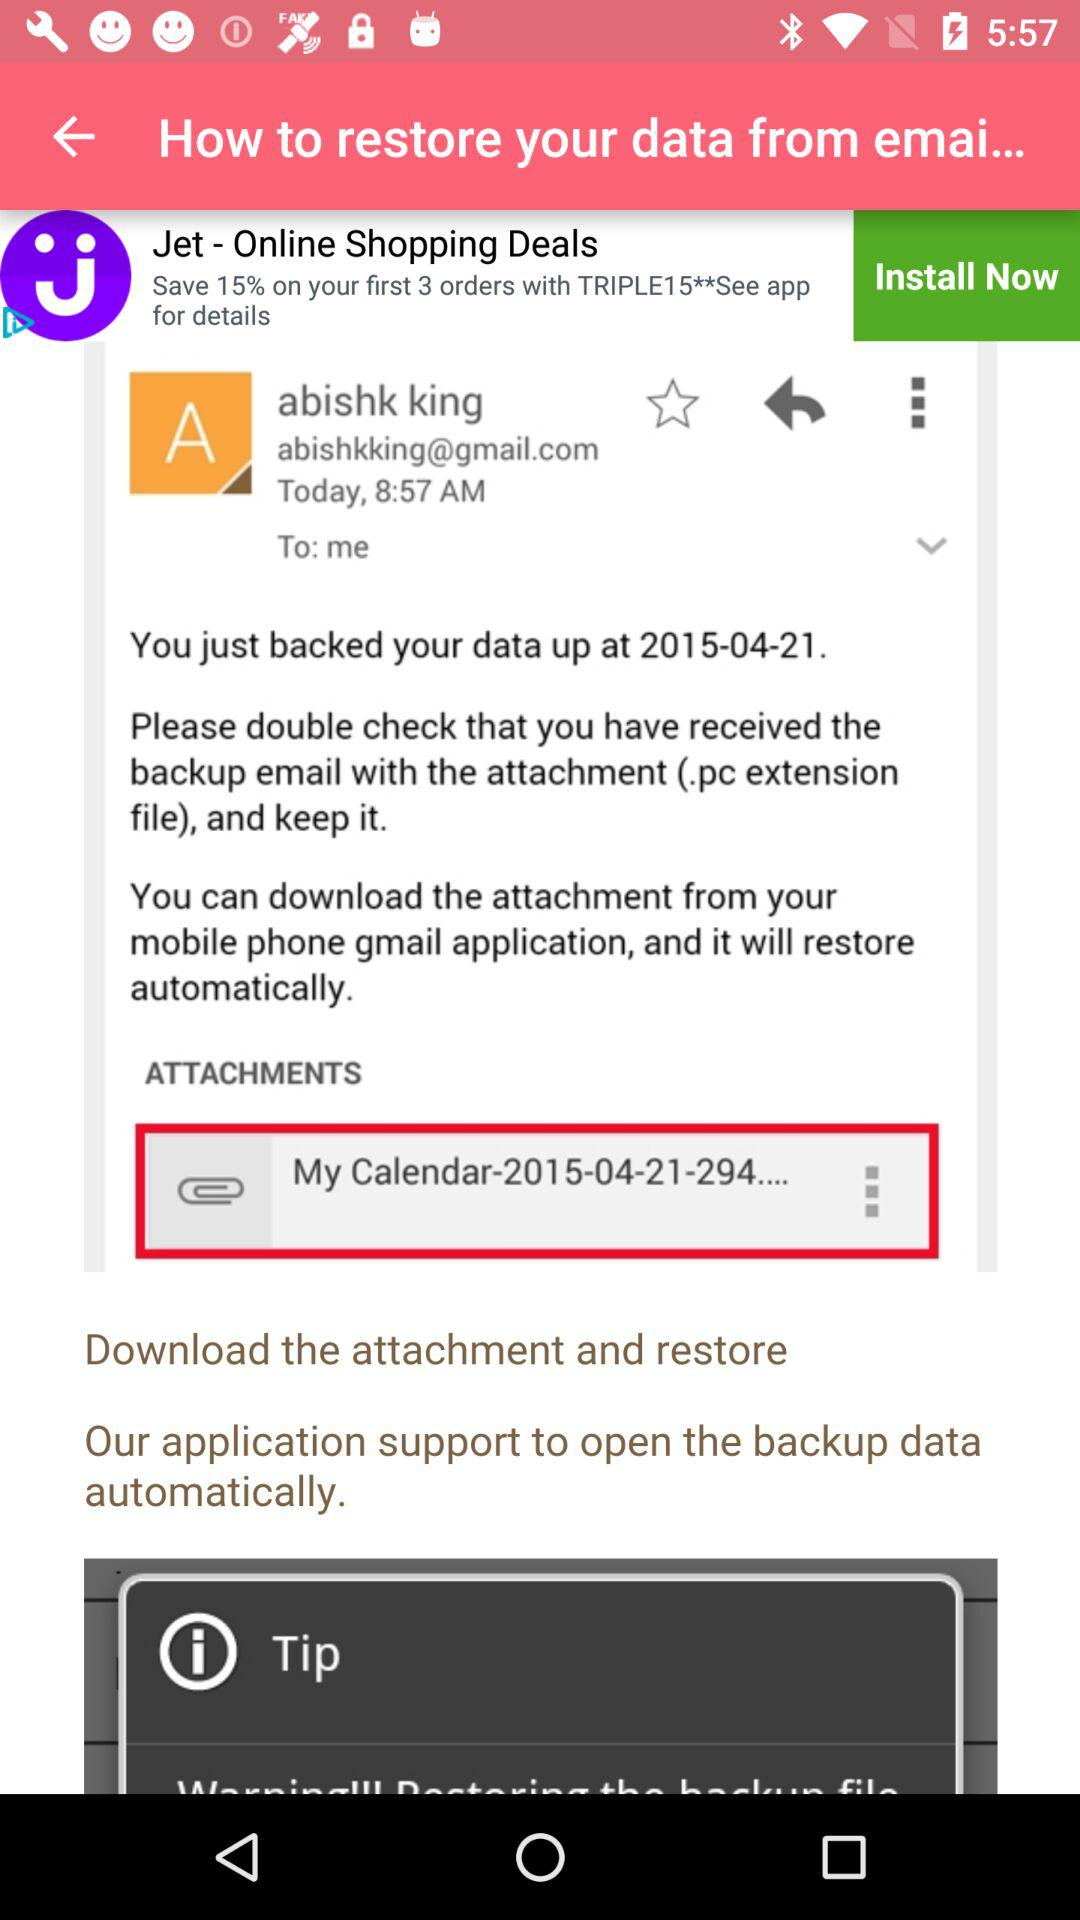How many attachments did the user receive?
Answer the question using a single word or phrase. 1 